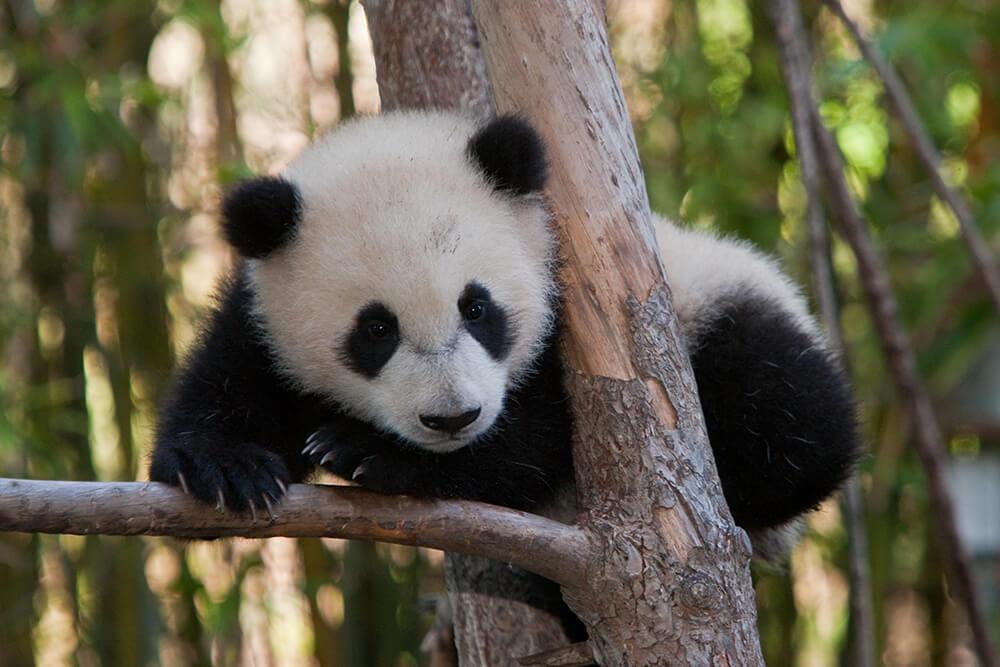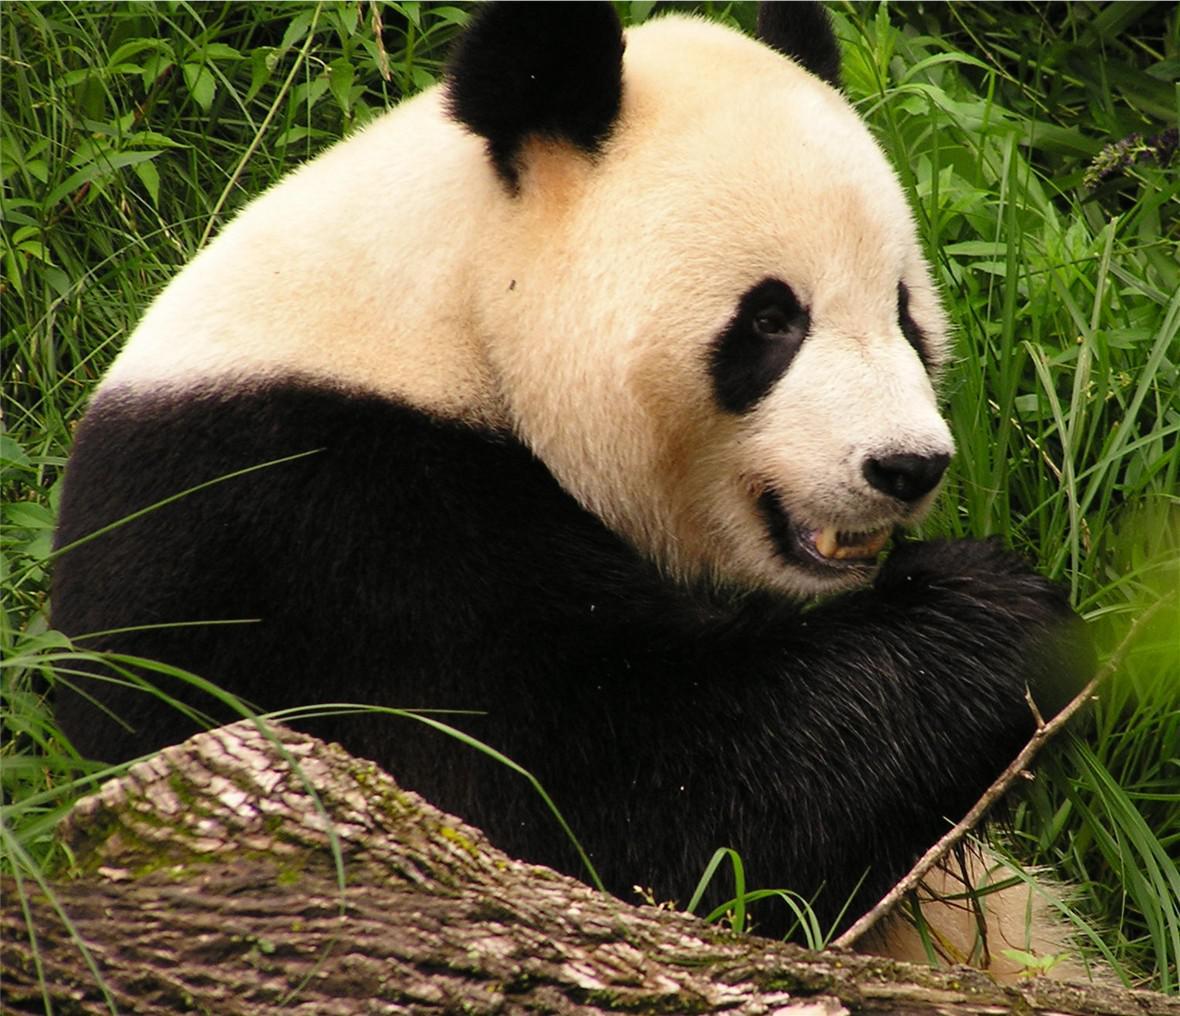The first image is the image on the left, the second image is the image on the right. Given the left and right images, does the statement "There are two pandas in the image on the right." hold true? Answer yes or no. No. 